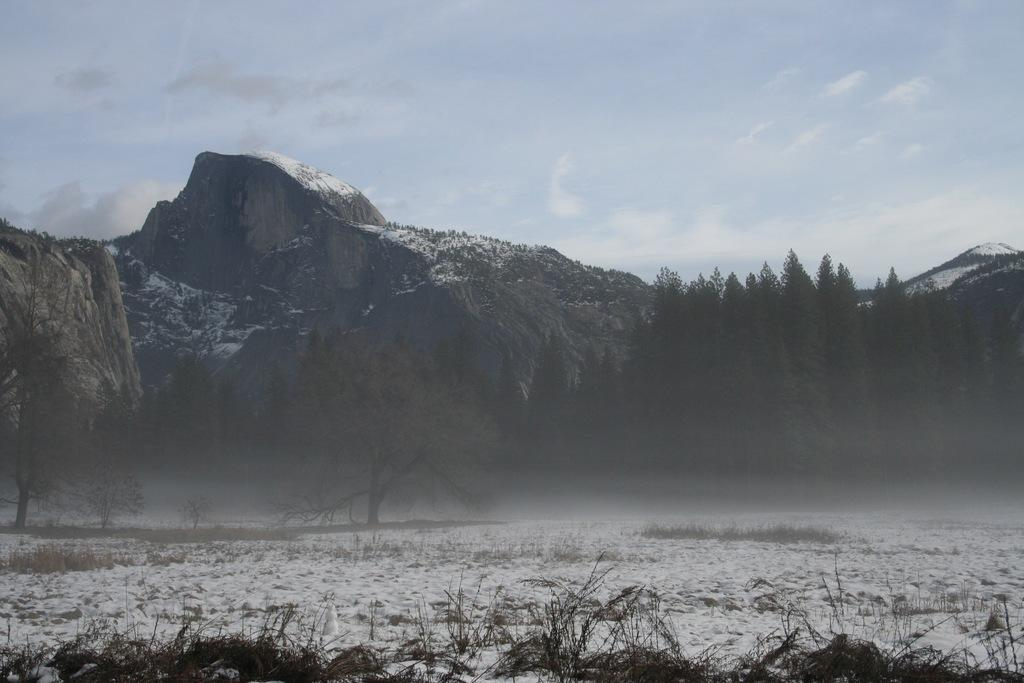What is the weather like in the image? The sky is cloudy in the image. What can be seen in the background of the image? There are mountains and trees in the background of the image. What is covering the land in the image? The land is covered with snow. How far away is the territory of the horned animals in the image? There are no horned animals or territories mentioned in the image; it features a cloudy sky, mountains, trees, and snow-covered land. 